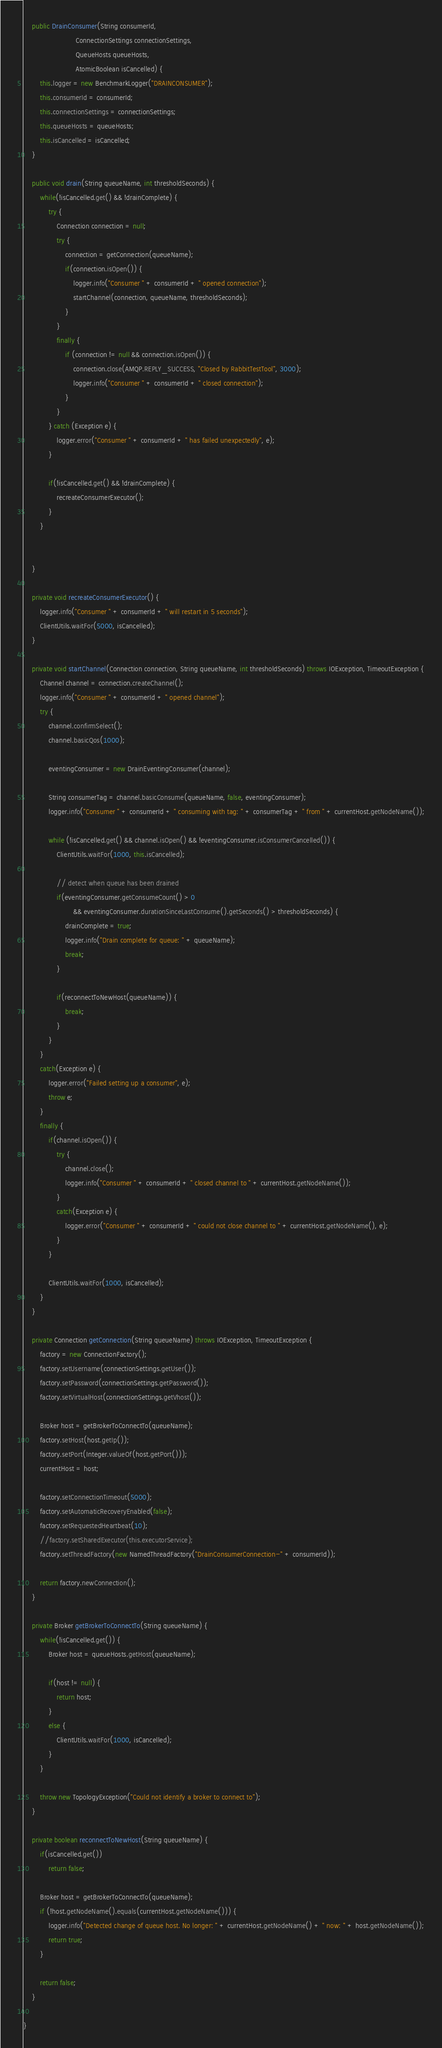<code> <loc_0><loc_0><loc_500><loc_500><_Java_>
    public DrainConsumer(String consumerId,
                         ConnectionSettings connectionSettings,
                         QueueHosts queueHosts,
                         AtomicBoolean isCancelled) {
        this.logger = new BenchmarkLogger("DRAINCONSUMER");
        this.consumerId = consumerId;
        this.connectionSettings = connectionSettings;
        this.queueHosts = queueHosts;
        this.isCancelled = isCancelled;
    }

    public void drain(String queueName, int thresholdSeconds) {
        while(!isCancelled.get() && !drainComplete) {
            try {
                Connection connection = null;
                try {
                    connection = getConnection(queueName);
                    if(connection.isOpen()) {
                        logger.info("Consumer " + consumerId + " opened connection");
                        startChannel(connection, queueName, thresholdSeconds);
                    }
                }
                finally {
                    if (connection != null && connection.isOpen()) {
                        connection.close(AMQP.REPLY_SUCCESS, "Closed by RabbitTestTool", 3000);
                        logger.info("Consumer " + consumerId + " closed connection");
                    }
                }
            } catch (Exception e) {
                logger.error("Consumer " + consumerId + " has failed unexpectedly", e);
            }

            if(!isCancelled.get() && !drainComplete) {
                recreateConsumerExecutor();
            }
        }


    }

    private void recreateConsumerExecutor() {
        logger.info("Consumer " + consumerId + " will restart in 5 seconds");
        ClientUtils.waitFor(5000, isCancelled);
    }

    private void startChannel(Connection connection, String queueName, int thresholdSeconds) throws IOException, TimeoutException {
        Channel channel = connection.createChannel();
        logger.info("Consumer " + consumerId + " opened channel");
        try {
            channel.confirmSelect();
            channel.basicQos(1000);

            eventingConsumer = new DrainEventingConsumer(channel);

            String consumerTag = channel.basicConsume(queueName, false, eventingConsumer);
            logger.info("Consumer " + consumerId + " consuming with tag: " + consumerTag + " from " + currentHost.getNodeName());

            while (!isCancelled.get() && channel.isOpen() && !eventingConsumer.isConsumerCancelled()) {
                ClientUtils.waitFor(1000, this.isCancelled);

                // detect when queue has been drained
                if(eventingConsumer.getConsumeCount() > 0
                        && eventingConsumer.durationSinceLastConsume().getSeconds() > thresholdSeconds) {
                    drainComplete = true;
                    logger.info("Drain complete for queue: " + queueName);
                    break;
                }

                if(reconnectToNewHost(queueName)) {
                    break;
                }
            }
        }
        catch(Exception e) {
            logger.error("Failed setting up a consumer", e);
            throw e;
        }
        finally {
            if(channel.isOpen()) {
                try {
                    channel.close();
                    logger.info("Consumer " + consumerId + " closed channel to " + currentHost.getNodeName());
                }
                catch(Exception e) {
                    logger.error("Consumer " + consumerId + " could not close channel to " + currentHost.getNodeName(), e);
                }
            }

            ClientUtils.waitFor(1000, isCancelled);
        }
    }

    private Connection getConnection(String queueName) throws IOException, TimeoutException {
        factory = new ConnectionFactory();
        factory.setUsername(connectionSettings.getUser());
        factory.setPassword(connectionSettings.getPassword());
        factory.setVirtualHost(connectionSettings.getVhost());

        Broker host = getBrokerToConnectTo(queueName);
        factory.setHost(host.getIp());
        factory.setPort(Integer.valueOf(host.getPort()));
        currentHost = host;

        factory.setConnectionTimeout(5000);
        factory.setAutomaticRecoveryEnabled(false);
        factory.setRequestedHeartbeat(10);
        //factory.setSharedExecutor(this.executorService);
        factory.setThreadFactory(new NamedThreadFactory("DrainConsumerConnection-" + consumerId));

        return factory.newConnection();
    }

    private Broker getBrokerToConnectTo(String queueName) {
        while(!isCancelled.get()) {
            Broker host = queueHosts.getHost(queueName);

            if(host != null) {
                return host;
            }
            else {
                ClientUtils.waitFor(1000, isCancelled);
            }
        }

        throw new TopologyException("Could not identify a broker to connect to");
    }

    private boolean reconnectToNewHost(String queueName) {
        if(isCancelled.get())
            return false;

        Broker host = getBrokerToConnectTo(queueName);
        if (!host.getNodeName().equals(currentHost.getNodeName())) {
            logger.info("Detected change of queue host. No longer: " + currentHost.getNodeName() + " now: " + host.getNodeName());
            return true;
        }

        return false;
    }

}
</code> 